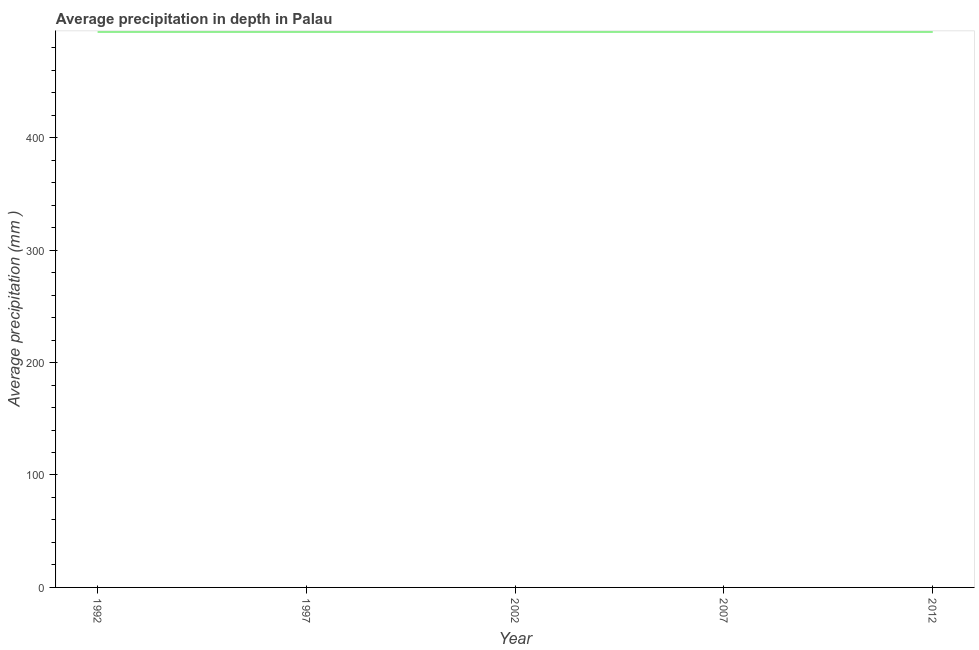What is the average precipitation in depth in 1992?
Provide a succinct answer. 494. Across all years, what is the maximum average precipitation in depth?
Your answer should be very brief. 494. Across all years, what is the minimum average precipitation in depth?
Provide a short and direct response. 494. What is the sum of the average precipitation in depth?
Give a very brief answer. 2470. What is the average average precipitation in depth per year?
Your answer should be compact. 494. What is the median average precipitation in depth?
Make the answer very short. 494. In how many years, is the average precipitation in depth greater than 140 mm?
Offer a very short reply. 5. What is the ratio of the average precipitation in depth in 1997 to that in 2002?
Provide a succinct answer. 1. Is the average precipitation in depth in 1997 less than that in 2012?
Offer a terse response. No. Is the difference between the average precipitation in depth in 2002 and 2012 greater than the difference between any two years?
Offer a terse response. Yes. What is the difference between the highest and the second highest average precipitation in depth?
Your answer should be very brief. 0. What is the difference between the highest and the lowest average precipitation in depth?
Offer a very short reply. 0. Does the average precipitation in depth monotonically increase over the years?
Give a very brief answer. No. How many lines are there?
Your answer should be compact. 1. Are the values on the major ticks of Y-axis written in scientific E-notation?
Ensure brevity in your answer.  No. Does the graph contain grids?
Your answer should be very brief. No. What is the title of the graph?
Keep it short and to the point. Average precipitation in depth in Palau. What is the label or title of the Y-axis?
Make the answer very short. Average precipitation (mm ). What is the Average precipitation (mm ) in 1992?
Offer a terse response. 494. What is the Average precipitation (mm ) in 1997?
Give a very brief answer. 494. What is the Average precipitation (mm ) in 2002?
Your answer should be very brief. 494. What is the Average precipitation (mm ) in 2007?
Keep it short and to the point. 494. What is the Average precipitation (mm ) of 2012?
Make the answer very short. 494. What is the difference between the Average precipitation (mm ) in 1992 and 2002?
Ensure brevity in your answer.  0. What is the difference between the Average precipitation (mm ) in 1992 and 2007?
Give a very brief answer. 0. What is the difference between the Average precipitation (mm ) in 1992 and 2012?
Keep it short and to the point. 0. What is the difference between the Average precipitation (mm ) in 1997 and 2012?
Ensure brevity in your answer.  0. What is the difference between the Average precipitation (mm ) in 2002 and 2007?
Keep it short and to the point. 0. What is the ratio of the Average precipitation (mm ) in 1992 to that in 1997?
Provide a short and direct response. 1. What is the ratio of the Average precipitation (mm ) in 1992 to that in 2002?
Provide a short and direct response. 1. What is the ratio of the Average precipitation (mm ) in 1997 to that in 2002?
Make the answer very short. 1. What is the ratio of the Average precipitation (mm ) in 1997 to that in 2007?
Make the answer very short. 1. What is the ratio of the Average precipitation (mm ) in 1997 to that in 2012?
Offer a very short reply. 1. What is the ratio of the Average precipitation (mm ) in 2002 to that in 2007?
Your answer should be compact. 1. 